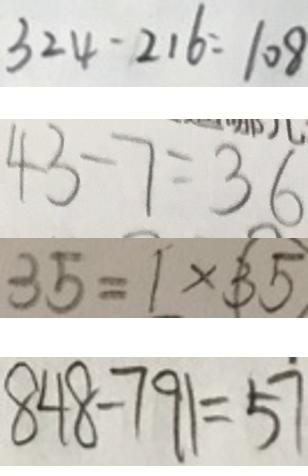Convert formula to latex. <formula><loc_0><loc_0><loc_500><loc_500>3 2 4 - 2 1 6 = 1 0 8 
 4 3 - 7 = 3 6 
 3 5 = 1 \times 3 5 
 8 4 8 - 7 9 1 = 5 7</formula> 